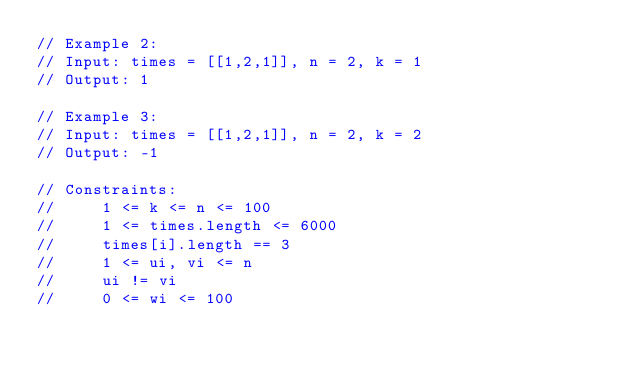Convert code to text. <code><loc_0><loc_0><loc_500><loc_500><_C++_>// Example 2:
// Input: times = [[1,2,1]], n = 2, k = 1
// Output: 1

// Example 3:
// Input: times = [[1,2,1]], n = 2, k = 2
// Output: -1

// Constraints:
//     1 <= k <= n <= 100
//     1 <= times.length <= 6000
//     times[i].length == 3
//     1 <= ui, vi <= n
//     ui != vi
//     0 <= wi <= 100</code> 